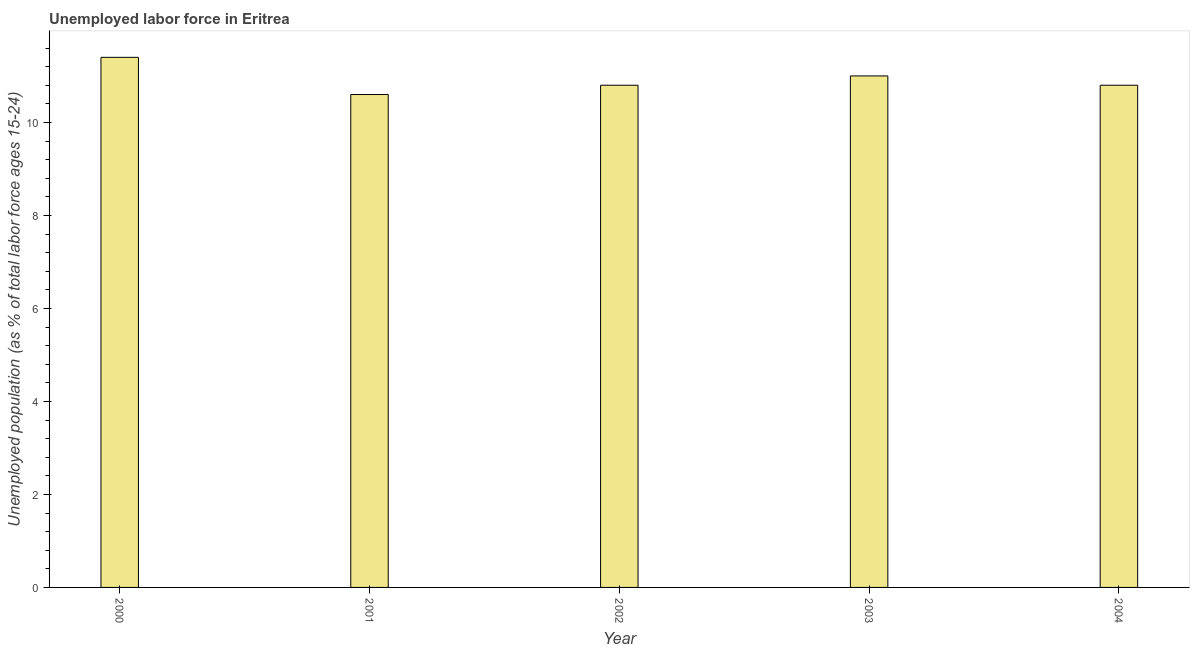Does the graph contain any zero values?
Your answer should be very brief. No. Does the graph contain grids?
Your answer should be very brief. No. What is the title of the graph?
Provide a succinct answer. Unemployed labor force in Eritrea. What is the label or title of the X-axis?
Your answer should be compact. Year. What is the label or title of the Y-axis?
Your answer should be very brief. Unemployed population (as % of total labor force ages 15-24). What is the total unemployed youth population in 2002?
Offer a very short reply. 10.8. Across all years, what is the maximum total unemployed youth population?
Offer a terse response. 11.4. Across all years, what is the minimum total unemployed youth population?
Keep it short and to the point. 10.6. In which year was the total unemployed youth population minimum?
Make the answer very short. 2001. What is the sum of the total unemployed youth population?
Provide a succinct answer. 54.6. What is the average total unemployed youth population per year?
Keep it short and to the point. 10.92. What is the median total unemployed youth population?
Your response must be concise. 10.8. In how many years, is the total unemployed youth population greater than 2 %?
Your response must be concise. 5. Do a majority of the years between 2003 and 2000 (inclusive) have total unemployed youth population greater than 5.6 %?
Your answer should be compact. Yes. Is the total unemployed youth population in 2000 less than that in 2002?
Provide a succinct answer. No. Is the difference between the total unemployed youth population in 2000 and 2004 greater than the difference between any two years?
Your answer should be very brief. No. Is the sum of the total unemployed youth population in 2003 and 2004 greater than the maximum total unemployed youth population across all years?
Give a very brief answer. Yes. In how many years, is the total unemployed youth population greater than the average total unemployed youth population taken over all years?
Offer a very short reply. 2. Are all the bars in the graph horizontal?
Offer a very short reply. No. How many years are there in the graph?
Offer a terse response. 5. Are the values on the major ticks of Y-axis written in scientific E-notation?
Provide a succinct answer. No. What is the Unemployed population (as % of total labor force ages 15-24) of 2000?
Offer a terse response. 11.4. What is the Unemployed population (as % of total labor force ages 15-24) of 2001?
Offer a very short reply. 10.6. What is the Unemployed population (as % of total labor force ages 15-24) of 2002?
Offer a very short reply. 10.8. What is the Unemployed population (as % of total labor force ages 15-24) in 2003?
Provide a short and direct response. 11. What is the Unemployed population (as % of total labor force ages 15-24) in 2004?
Offer a very short reply. 10.8. What is the difference between the Unemployed population (as % of total labor force ages 15-24) in 2000 and 2001?
Your answer should be very brief. 0.8. What is the difference between the Unemployed population (as % of total labor force ages 15-24) in 2000 and 2003?
Make the answer very short. 0.4. What is the difference between the Unemployed population (as % of total labor force ages 15-24) in 2001 and 2002?
Give a very brief answer. -0.2. What is the ratio of the Unemployed population (as % of total labor force ages 15-24) in 2000 to that in 2001?
Provide a succinct answer. 1.07. What is the ratio of the Unemployed population (as % of total labor force ages 15-24) in 2000 to that in 2002?
Provide a succinct answer. 1.06. What is the ratio of the Unemployed population (as % of total labor force ages 15-24) in 2000 to that in 2003?
Your answer should be compact. 1.04. What is the ratio of the Unemployed population (as % of total labor force ages 15-24) in 2000 to that in 2004?
Your answer should be very brief. 1.06. What is the ratio of the Unemployed population (as % of total labor force ages 15-24) in 2001 to that in 2002?
Your answer should be compact. 0.98. What is the ratio of the Unemployed population (as % of total labor force ages 15-24) in 2002 to that in 2003?
Ensure brevity in your answer.  0.98. What is the ratio of the Unemployed population (as % of total labor force ages 15-24) in 2002 to that in 2004?
Give a very brief answer. 1. What is the ratio of the Unemployed population (as % of total labor force ages 15-24) in 2003 to that in 2004?
Offer a very short reply. 1.02. 